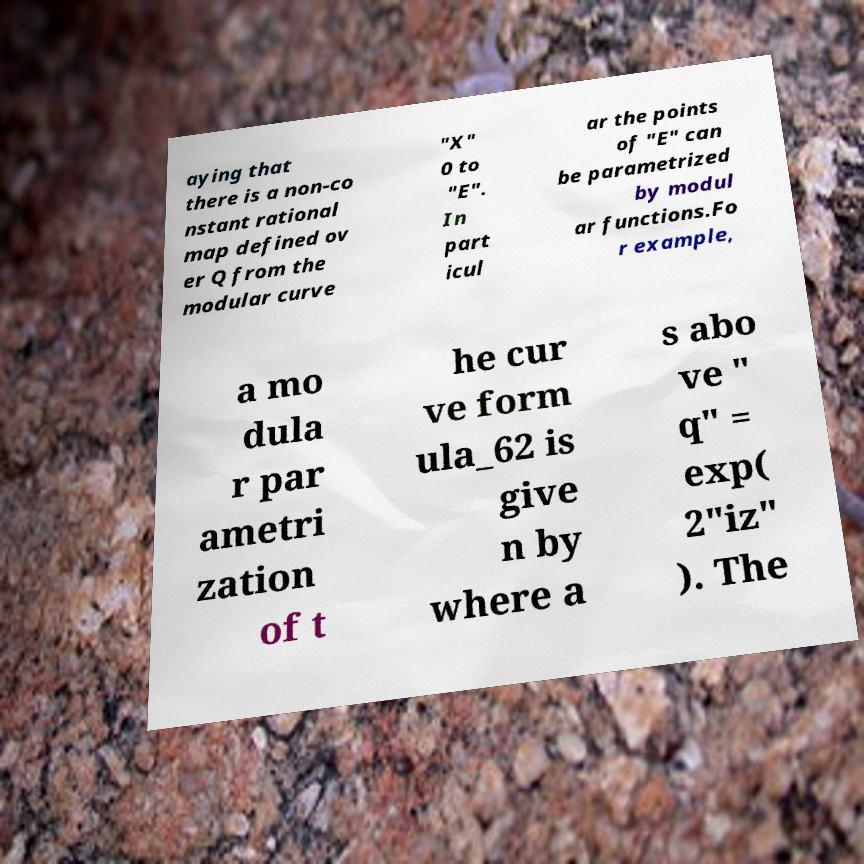For documentation purposes, I need the text within this image transcribed. Could you provide that? aying that there is a non-co nstant rational map defined ov er Q from the modular curve "X" 0 to "E". In part icul ar the points of "E" can be parametrized by modul ar functions.Fo r example, a mo dula r par ametri zation of t he cur ve form ula_62 is give n by where a s abo ve " q" = exp( 2"iz" ). The 